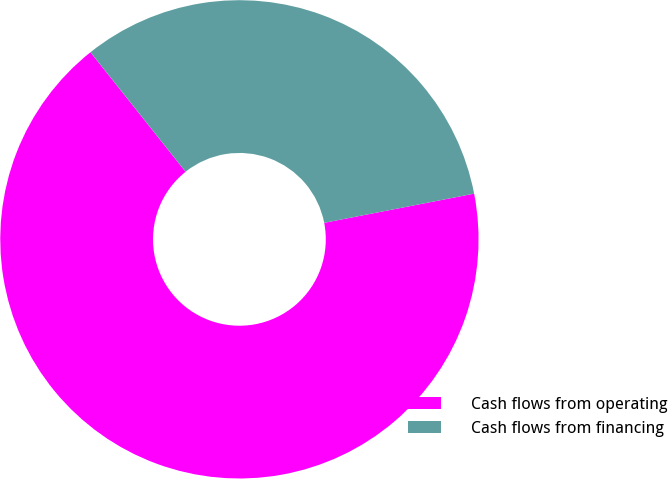Convert chart to OTSL. <chart><loc_0><loc_0><loc_500><loc_500><pie_chart><fcel>Cash flows from operating<fcel>Cash flows from financing<nl><fcel>67.36%<fcel>32.64%<nl></chart> 